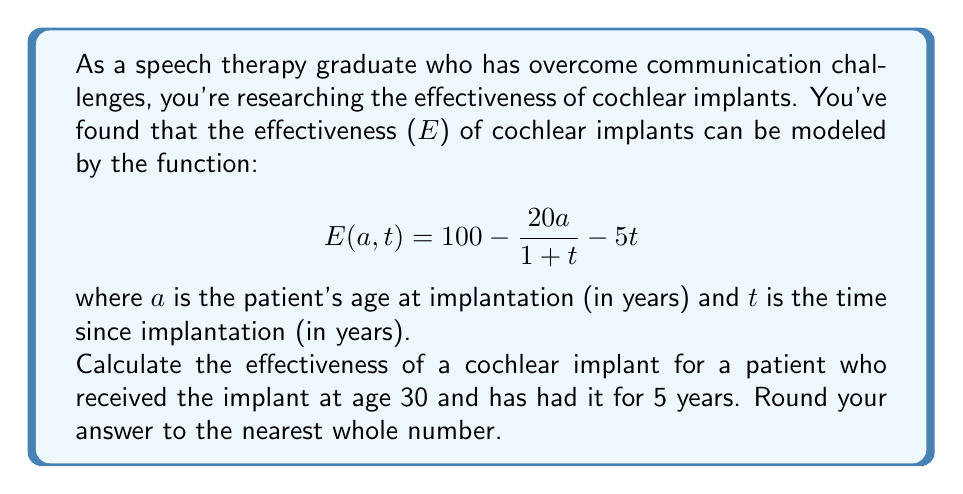Teach me how to tackle this problem. To solve this problem, we need to follow these steps:

1. Identify the given values:
   $a = 30$ (age at implantation)
   $t = 5$ (time since implantation)

2. Substitute these values into the effectiveness function:
   $$E(a, t) = 100 - \frac{20a}{1 + t} - 5t$$
   $$E(30, 5) = 100 - \frac{20(30)}{1 + 5} - 5(5)$$

3. Simplify the expression:
   $$E(30, 5) = 100 - \frac{600}{6} - 25$$
   $$E(30, 5) = 100 - 100 - 25$$

4. Calculate the final result:
   $$E(30, 5) = -25$$

5. Since effectiveness cannot be negative in this context, we interpret this as 0% effectiveness.

6. Round to the nearest whole number (which is already done in this case).
Answer: 0% 